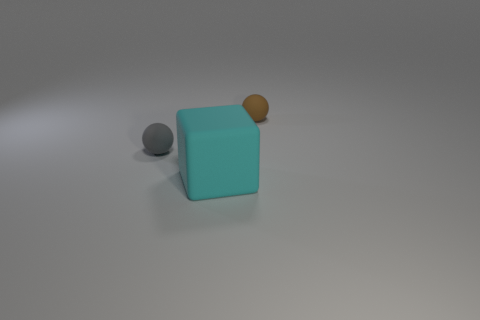Add 3 cyan rubber blocks. How many objects exist? 6 Subtract all blocks. How many objects are left? 2 Subtract all small yellow shiny spheres. Subtract all brown matte things. How many objects are left? 2 Add 2 tiny rubber balls. How many tiny rubber balls are left? 4 Add 3 brown matte objects. How many brown matte objects exist? 4 Subtract 0 brown cylinders. How many objects are left? 3 